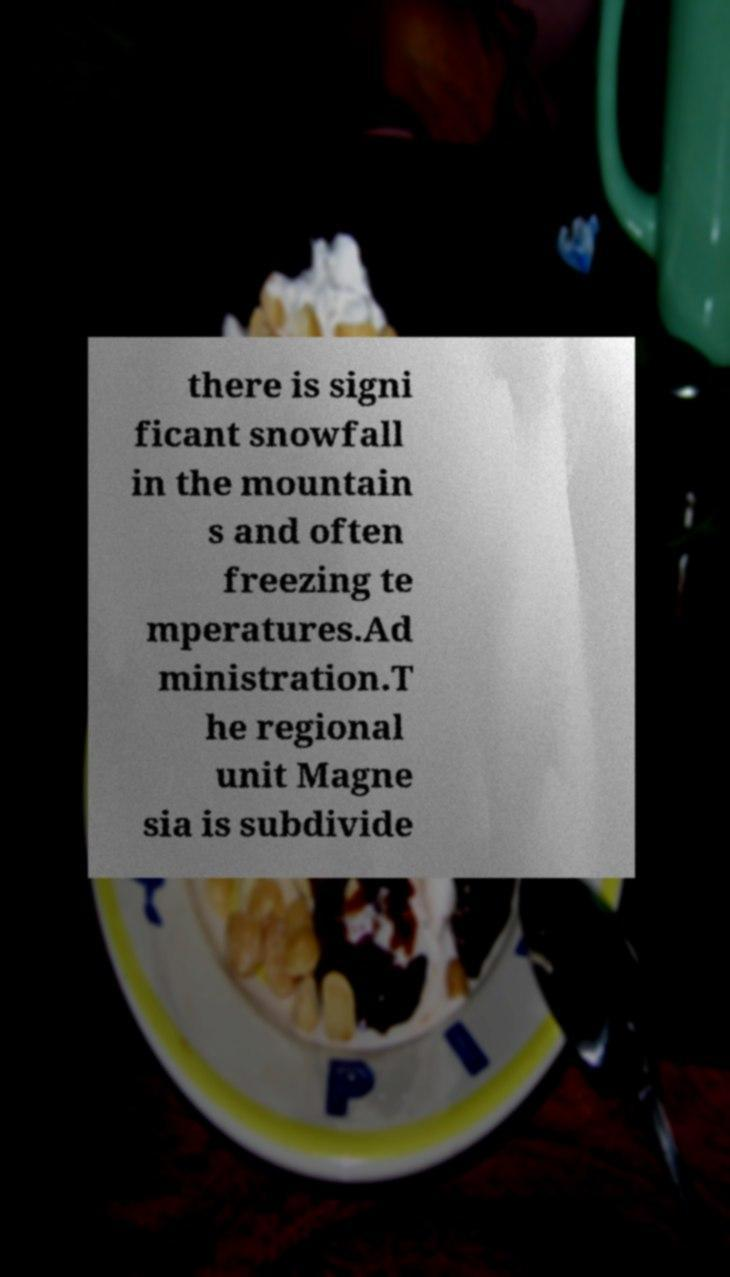For documentation purposes, I need the text within this image transcribed. Could you provide that? there is signi ficant snowfall in the mountain s and often freezing te mperatures.Ad ministration.T he regional unit Magne sia is subdivide 